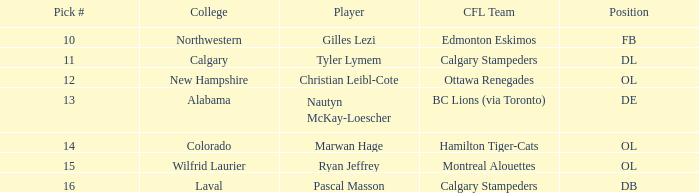What place does christian leibl-cote hold? OL. 